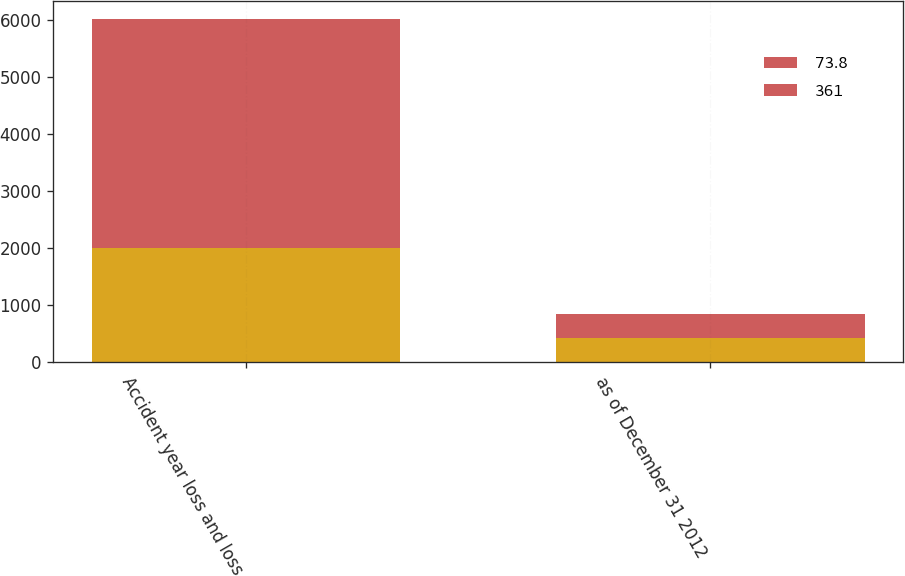<chart> <loc_0><loc_0><loc_500><loc_500><stacked_bar_chart><ecel><fcel>Accident year loss and loss<fcel>as of December 31 2012<nl><fcel>nan<fcel>2012<fcel>424<nl><fcel>73.8<fcel>2010<fcel>347<nl><fcel>361<fcel>2010<fcel>71<nl></chart> 